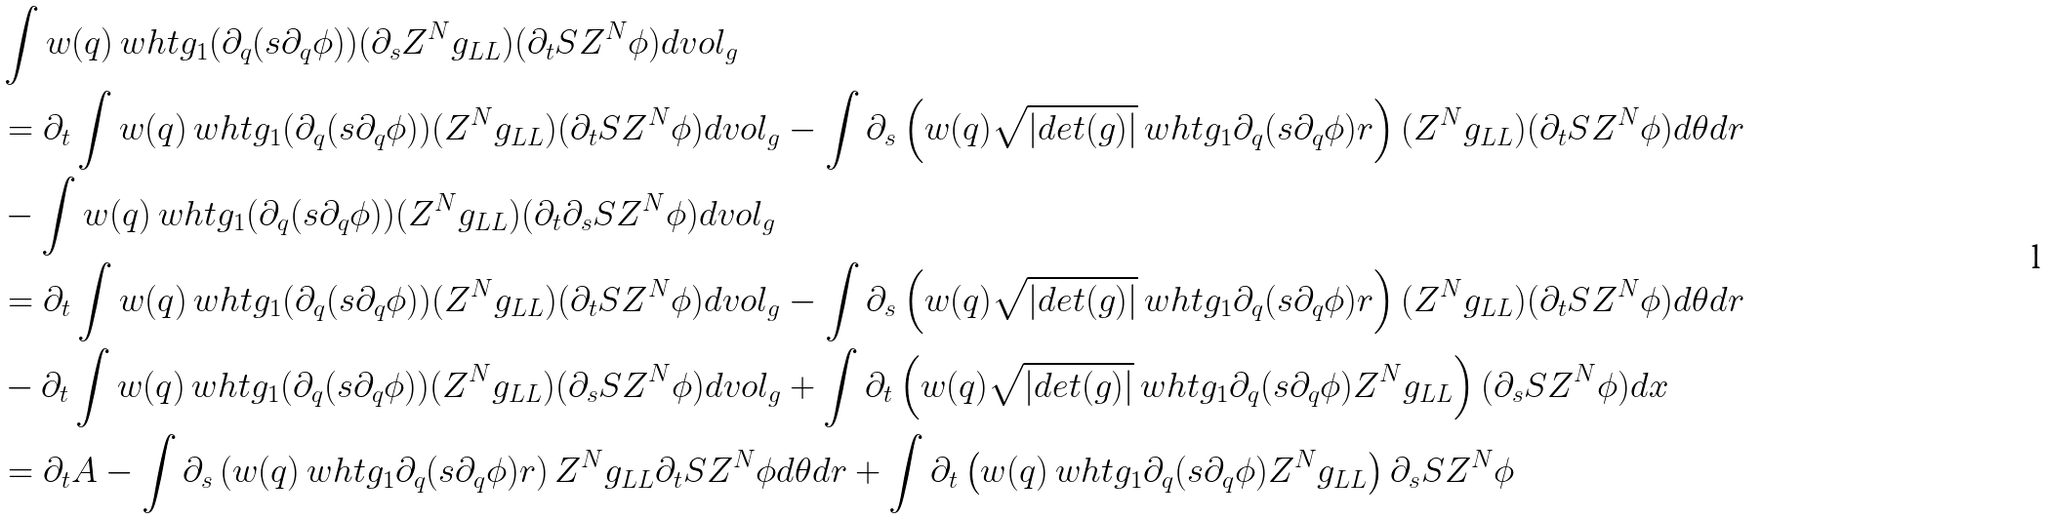<formula> <loc_0><loc_0><loc_500><loc_500>& \int w ( q ) \ w h t g _ { 1 } ( \partial _ { q } ( s \partial _ { q } \phi ) ) ( \partial _ { s } Z ^ { N } g _ { L L } ) ( \partial _ { t } S Z ^ { N } \phi ) d v o l _ { g } \\ & = \partial _ { t } \int w ( q ) \ w h t g _ { 1 } ( \partial _ { q } ( s \partial _ { q } \phi ) ) ( Z ^ { N } g _ { L L } ) ( \partial _ { t } S Z ^ { N } \phi ) d v o l _ { g } - \int \partial _ { s } \left ( w ( q ) \sqrt { | d e t ( g ) | } \ w h t g _ { 1 } \partial _ { q } ( s \partial _ { q } \phi ) r \right ) ( Z ^ { N } g _ { L L } ) ( \partial _ { t } S Z ^ { N } \phi ) d \theta d r \\ & - \int w ( q ) \ w h t g _ { 1 } ( \partial _ { q } ( s \partial _ { q } \phi ) ) ( Z ^ { N } g _ { L L } ) ( \partial _ { t } \partial _ { s } S Z ^ { N } \phi ) d v o l _ { g } \\ & = \partial _ { t } \int w ( q ) \ w h t g _ { 1 } ( \partial _ { q } ( s \partial _ { q } \phi ) ) ( Z ^ { N } g _ { L L } ) ( \partial _ { t } S Z ^ { N } \phi ) d v o l _ { g } - \int \partial _ { s } \left ( w ( q ) \sqrt { | d e t ( g ) | } \ w h t g _ { 1 } \partial _ { q } ( s \partial _ { q } \phi ) r \right ) ( Z ^ { N } g _ { L L } ) ( \partial _ { t } S Z ^ { N } \phi ) d \theta d r \\ & - \partial _ { t } \int w ( q ) \ w h t g _ { 1 } ( \partial _ { q } ( s \partial _ { q } \phi ) ) ( Z ^ { N } g _ { L L } ) ( \partial _ { s } S Z ^ { N } \phi ) d v o l _ { g } + \int \partial _ { t } \left ( w ( q ) \sqrt { | d e t ( g ) | } \ w h t g _ { 1 } \partial _ { q } ( s \partial _ { q } \phi ) Z ^ { N } g _ { L L } \right ) ( \partial _ { s } S Z ^ { N } \phi ) d x \\ & = \partial _ { t } A - \int \partial _ { s } \left ( w ( q ) \ w h t g _ { 1 } \partial _ { q } ( s \partial _ { q } \phi ) r \right ) Z ^ { N } g _ { L L } \partial _ { t } S Z ^ { N } \phi d \theta d r + \int \partial _ { t } \left ( w ( q ) \ w h t g _ { 1 } \partial _ { q } ( s \partial _ { q } \phi ) Z ^ { N } g _ { L L } \right ) \partial _ { s } S Z ^ { N } \phi</formula> 